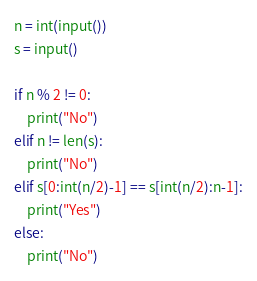<code> <loc_0><loc_0><loc_500><loc_500><_Python_>n = int(input())
s = input()

if n % 2 != 0:
    print("No")
elif n != len(s):
    print("No")
elif s[0:int(n/2)-1] == s[int(n/2):n-1]:
    print("Yes")
else:
    print("No")
</code> 